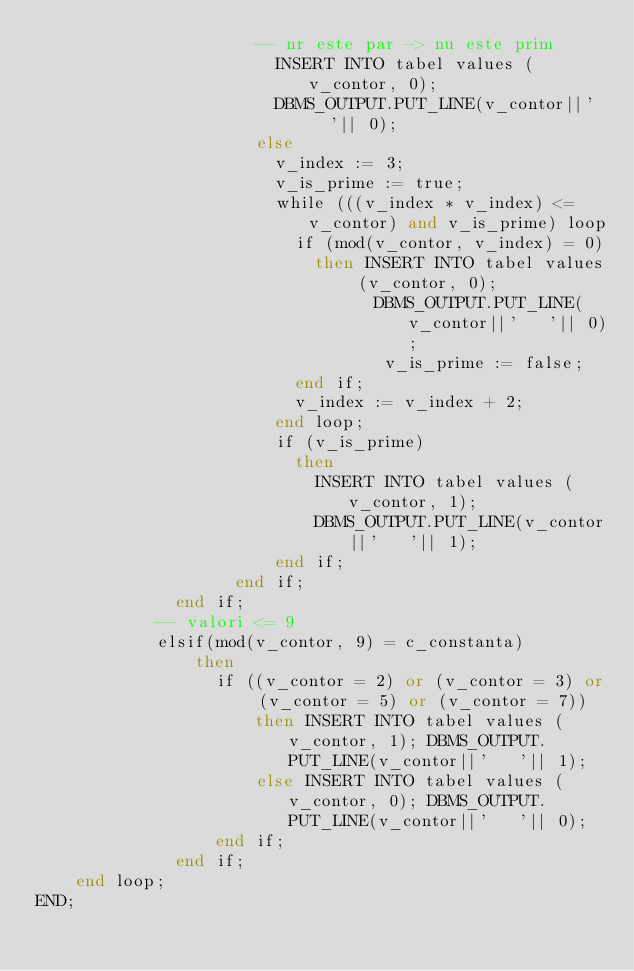<code> <loc_0><loc_0><loc_500><loc_500><_SQL_>                      -- nr este par -> nu este prim
                        INSERT INTO tabel values (v_contor, 0);
                        DBMS_OUTPUT.PUT_LINE(v_contor||'   '|| 0);
                      else 
                        v_index := 3;
                        v_is_prime := true;
                        while (((v_index * v_index) <= v_contor) and v_is_prime) loop
                          if (mod(v_contor, v_index) = 0) 
                            then INSERT INTO tabel values (v_contor, 0);
                                  DBMS_OUTPUT.PUT_LINE(v_contor||'   '|| 0);
                                   v_is_prime := false;
                          end if;
                          v_index := v_index + 2;
                        end loop;
                        if (v_is_prime)
                          then
                            INSERT INTO tabel values (v_contor, 1); 
                            DBMS_OUTPUT.PUT_LINE(v_contor||'   '|| 1);
                        end if;
                    end if; 
              end if;
            -- valori <= 9 
            elsif(mod(v_contor, 9) = c_constanta)
                then
                  if ((v_contor = 2) or (v_contor = 3) or (v_contor = 5) or (v_contor = 7))
                      then INSERT INTO tabel values (v_contor, 1); DBMS_OUTPUT.PUT_LINE(v_contor||'   '|| 1);
                      else INSERT INTO tabel values (v_contor, 0); DBMS_OUTPUT.PUT_LINE(v_contor||'   '|| 0);
                  end if;
              end if;
    end loop; 
END;</code> 